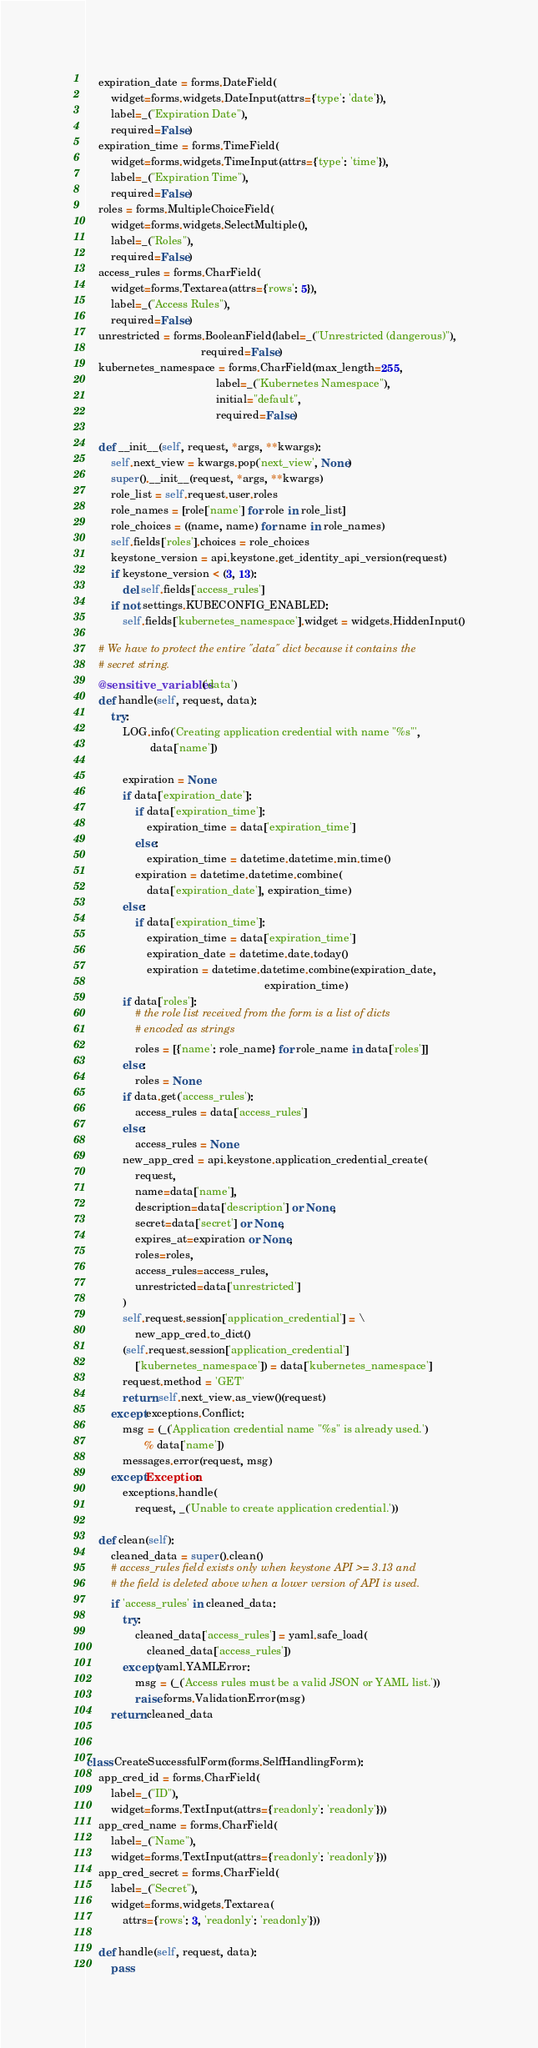<code> <loc_0><loc_0><loc_500><loc_500><_Python_>    expiration_date = forms.DateField(
        widget=forms.widgets.DateInput(attrs={'type': 'date'}),
        label=_("Expiration Date"),
        required=False)
    expiration_time = forms.TimeField(
        widget=forms.widgets.TimeInput(attrs={'type': 'time'}),
        label=_("Expiration Time"),
        required=False)
    roles = forms.MultipleChoiceField(
        widget=forms.widgets.SelectMultiple(),
        label=_("Roles"),
        required=False)
    access_rules = forms.CharField(
        widget=forms.Textarea(attrs={'rows': 5}),
        label=_("Access Rules"),
        required=False)
    unrestricted = forms.BooleanField(label=_("Unrestricted (dangerous)"),
                                      required=False)
    kubernetes_namespace = forms.CharField(max_length=255,
                                           label=_("Kubernetes Namespace"),
                                           initial="default",
                                           required=False)

    def __init__(self, request, *args, **kwargs):
        self.next_view = kwargs.pop('next_view', None)
        super().__init__(request, *args, **kwargs)
        role_list = self.request.user.roles
        role_names = [role['name'] for role in role_list]
        role_choices = ((name, name) for name in role_names)
        self.fields['roles'].choices = role_choices
        keystone_version = api.keystone.get_identity_api_version(request)
        if keystone_version < (3, 13):
            del self.fields['access_rules']
        if not settings.KUBECONFIG_ENABLED:
            self.fields['kubernetes_namespace'].widget = widgets.HiddenInput()

    # We have to protect the entire "data" dict because it contains the
    # secret string.
    @sensitive_variables('data')
    def handle(self, request, data):
        try:
            LOG.info('Creating application credential with name "%s"',
                     data['name'])

            expiration = None
            if data['expiration_date']:
                if data['expiration_time']:
                    expiration_time = data['expiration_time']
                else:
                    expiration_time = datetime.datetime.min.time()
                expiration = datetime.datetime.combine(
                    data['expiration_date'], expiration_time)
            else:
                if data['expiration_time']:
                    expiration_time = data['expiration_time']
                    expiration_date = datetime.date.today()
                    expiration = datetime.datetime.combine(expiration_date,
                                                           expiration_time)
            if data['roles']:
                # the role list received from the form is a list of dicts
                # encoded as strings
                roles = [{'name': role_name} for role_name in data['roles']]
            else:
                roles = None
            if data.get('access_rules'):
                access_rules = data['access_rules']
            else:
                access_rules = None
            new_app_cred = api.keystone.application_credential_create(
                request,
                name=data['name'],
                description=data['description'] or None,
                secret=data['secret'] or None,
                expires_at=expiration or None,
                roles=roles,
                access_rules=access_rules,
                unrestricted=data['unrestricted']
            )
            self.request.session['application_credential'] = \
                new_app_cred.to_dict()
            (self.request.session['application_credential']
                ['kubernetes_namespace']) = data['kubernetes_namespace']
            request.method = 'GET'
            return self.next_view.as_view()(request)
        except exceptions.Conflict:
            msg = (_('Application credential name "%s" is already used.')
                   % data['name'])
            messages.error(request, msg)
        except Exception:
            exceptions.handle(
                request, _('Unable to create application credential.'))

    def clean(self):
        cleaned_data = super().clean()
        # access_rules field exists only when keystone API >= 3.13 and
        # the field is deleted above when a lower version of API is used.
        if 'access_rules' in cleaned_data:
            try:
                cleaned_data['access_rules'] = yaml.safe_load(
                    cleaned_data['access_rules'])
            except yaml.YAMLError:
                msg = (_('Access rules must be a valid JSON or YAML list.'))
                raise forms.ValidationError(msg)
        return cleaned_data


class CreateSuccessfulForm(forms.SelfHandlingForm):
    app_cred_id = forms.CharField(
        label=_("ID"),
        widget=forms.TextInput(attrs={'readonly': 'readonly'}))
    app_cred_name = forms.CharField(
        label=_("Name"),
        widget=forms.TextInput(attrs={'readonly': 'readonly'}))
    app_cred_secret = forms.CharField(
        label=_("Secret"),
        widget=forms.widgets.Textarea(
            attrs={'rows': 3, 'readonly': 'readonly'}))

    def handle(self, request, data):
        pass
</code> 